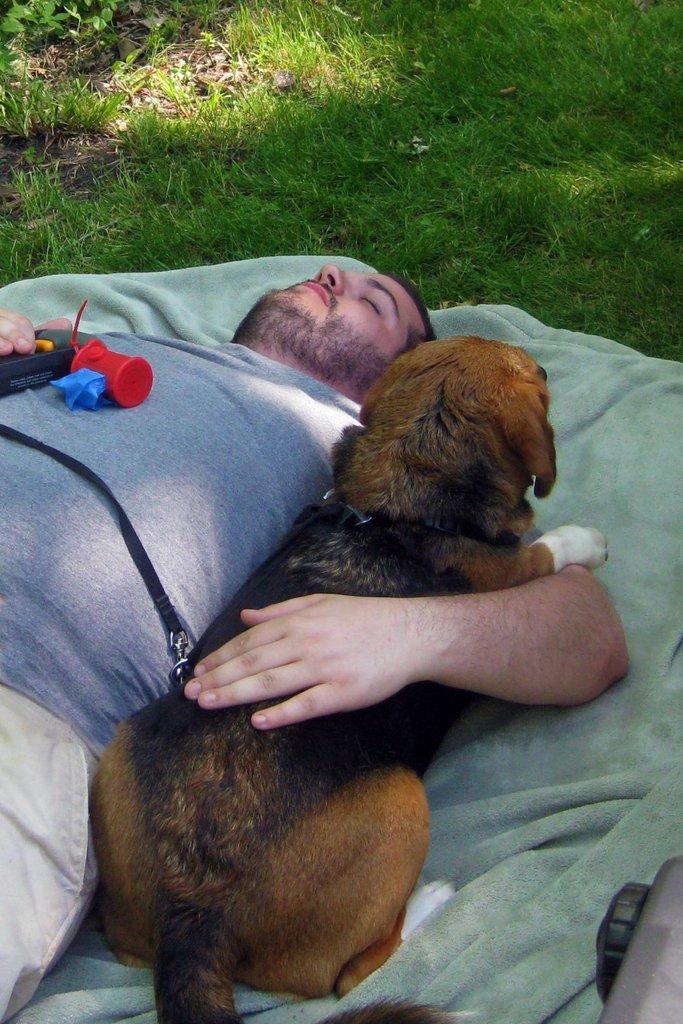Describe this image in one or two sentences. In this image In the middle there is a man he is sleeping he wears t shirt and trouser he holds a dog. In the background there is a grass and bed sheet. 